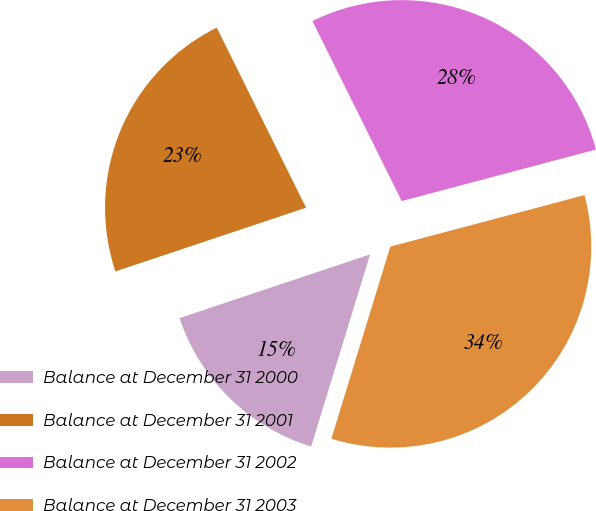Convert chart. <chart><loc_0><loc_0><loc_500><loc_500><pie_chart><fcel>Balance at December 31 2000<fcel>Balance at December 31 2001<fcel>Balance at December 31 2002<fcel>Balance at December 31 2003<nl><fcel>15.13%<fcel>22.81%<fcel>28.2%<fcel>33.87%<nl></chart> 